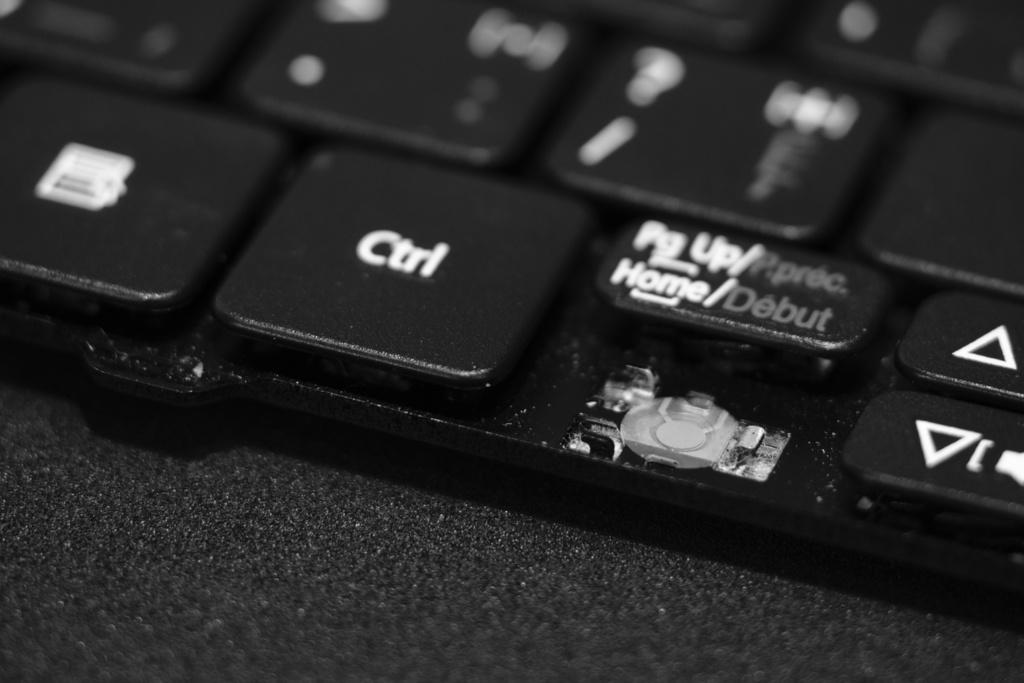<image>
Create a compact narrative representing the image presented. A close up of a black keyboard showing the ctrl button. 